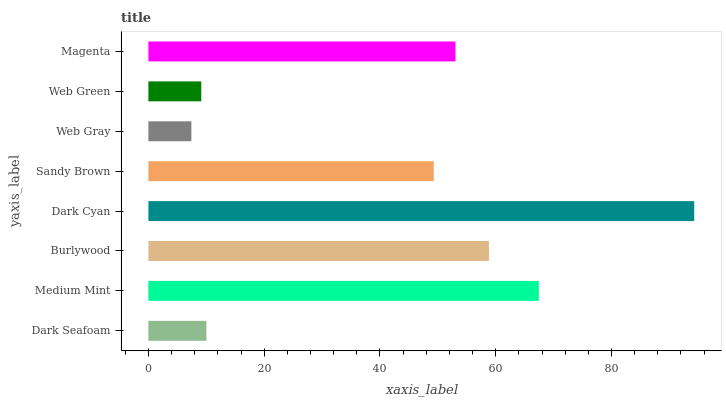Is Web Gray the minimum?
Answer yes or no. Yes. Is Dark Cyan the maximum?
Answer yes or no. Yes. Is Medium Mint the minimum?
Answer yes or no. No. Is Medium Mint the maximum?
Answer yes or no. No. Is Medium Mint greater than Dark Seafoam?
Answer yes or no. Yes. Is Dark Seafoam less than Medium Mint?
Answer yes or no. Yes. Is Dark Seafoam greater than Medium Mint?
Answer yes or no. No. Is Medium Mint less than Dark Seafoam?
Answer yes or no. No. Is Magenta the high median?
Answer yes or no. Yes. Is Sandy Brown the low median?
Answer yes or no. Yes. Is Medium Mint the high median?
Answer yes or no. No. Is Dark Seafoam the low median?
Answer yes or no. No. 